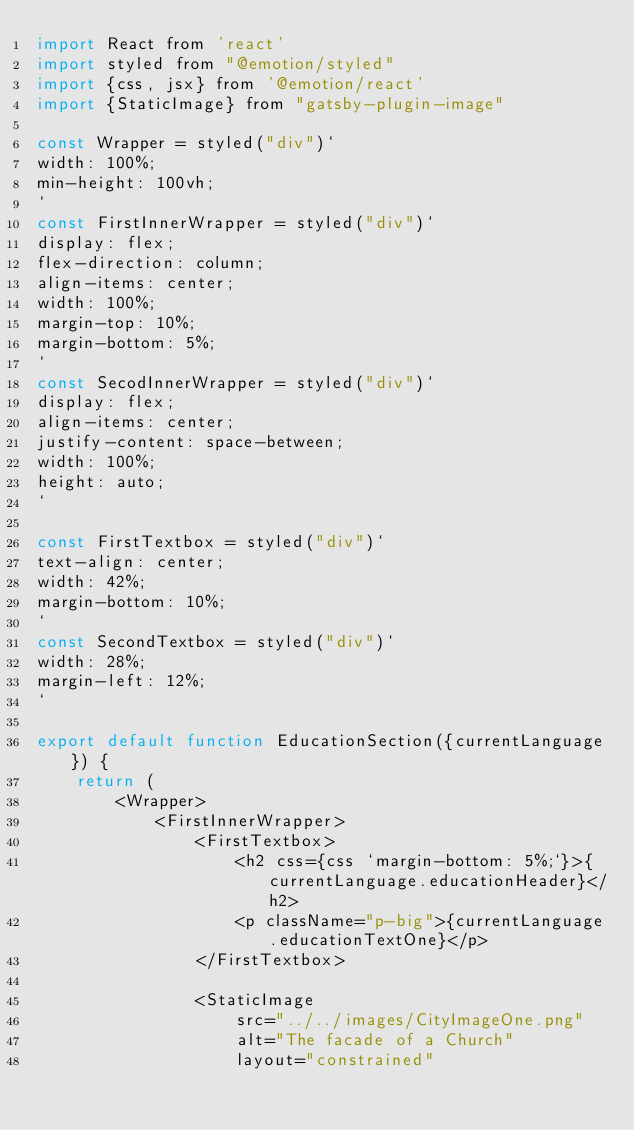<code> <loc_0><loc_0><loc_500><loc_500><_JavaScript_>import React from 'react'
import styled from "@emotion/styled"
import {css, jsx} from '@emotion/react'
import {StaticImage} from "gatsby-plugin-image"

const Wrapper = styled("div")`
width: 100%;
min-height: 100vh;
`
const FirstInnerWrapper = styled("div")`
display: flex;
flex-direction: column;
align-items: center;
width: 100%;
margin-top: 10%;
margin-bottom: 5%;
`
const SecodInnerWrapper = styled("div")`
display: flex;
align-items: center;
justify-content: space-between;
width: 100%;
height: auto;
`

const FirstTextbox = styled("div")`
text-align: center;
width: 42%;
margin-bottom: 10%;
`
const SecondTextbox = styled("div")`
width: 28%;
margin-left: 12%;
`

export default function EducationSection({currentLanguage}) {
    return (
        <Wrapper>
            <FirstInnerWrapper>
                <FirstTextbox>
                    <h2 css={css `margin-bottom: 5%;`}>{currentLanguage.educationHeader}</h2>
                    <p className="p-big">{currentLanguage.educationTextOne}</p>
                </FirstTextbox>

                <StaticImage
                    src="../../images/CityImageOne.png"
                    alt="The facade of a Church"
                    layout="constrained"               </code> 